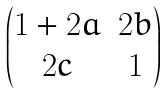Convert formula to latex. <formula><loc_0><loc_0><loc_500><loc_500>\begin{pmatrix} 1 + 2 a & 2 b \\ 2 c & 1 \end{pmatrix}</formula> 